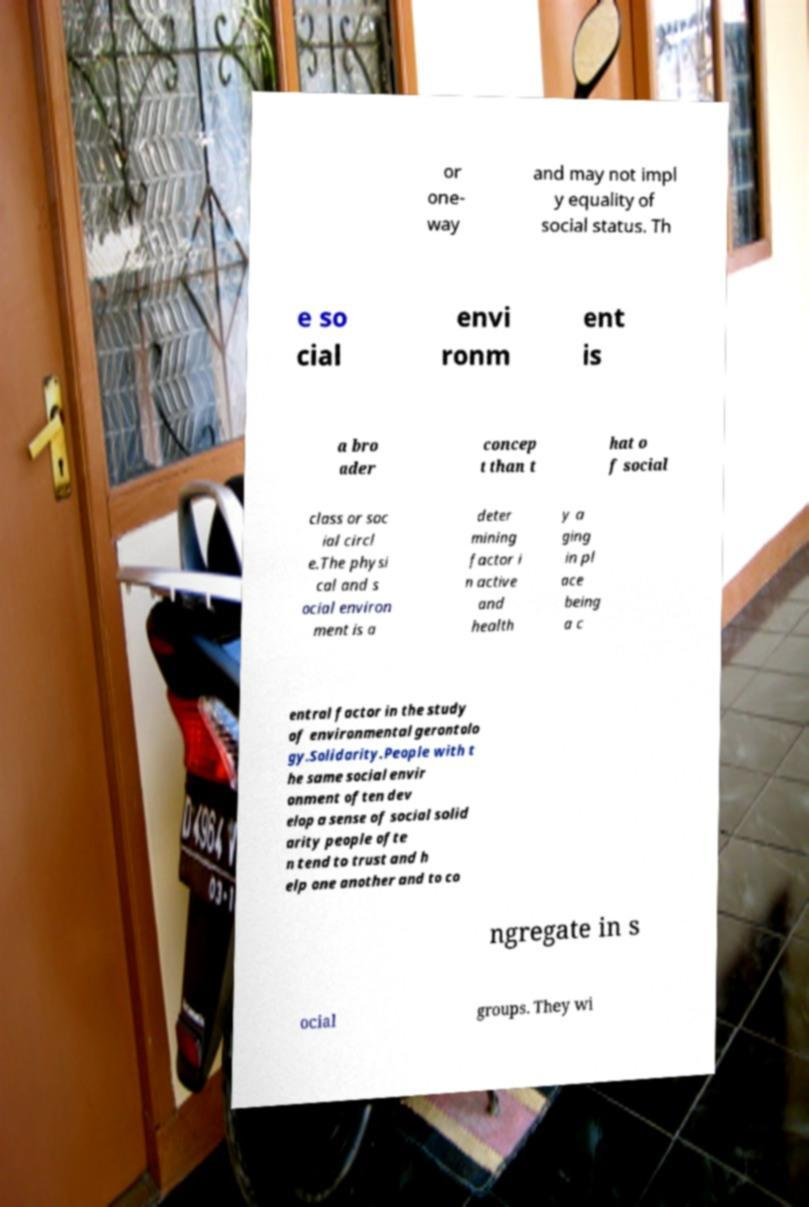Please identify and transcribe the text found in this image. or one- way and may not impl y equality of social status. Th e so cial envi ronm ent is a bro ader concep t than t hat o f social class or soc ial circl e.The physi cal and s ocial environ ment is a deter mining factor i n active and health y a ging in pl ace being a c entral factor in the study of environmental gerontolo gy.Solidarity.People with t he same social envir onment often dev elop a sense of social solid arity people ofte n tend to trust and h elp one another and to co ngregate in s ocial groups. They wi 